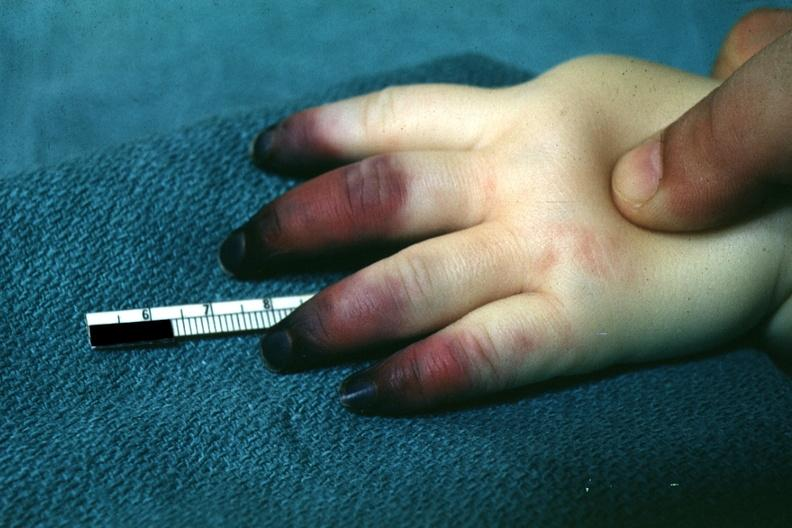s acrocyanosis present?
Answer the question using a single word or phrase. Yes 